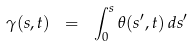Convert formula to latex. <formula><loc_0><loc_0><loc_500><loc_500>\gamma ( s , t ) \ = \ \int _ { 0 } ^ { s } \theta ( s ^ { \prime } , t ) \, d s ^ { \prime }</formula> 